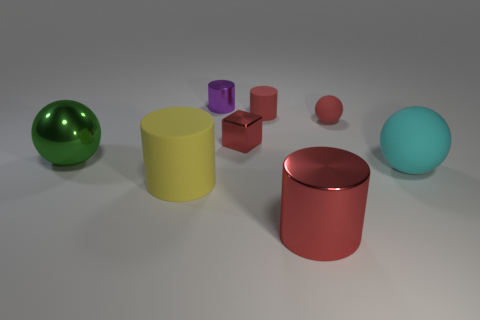What is the big yellow thing made of?
Make the answer very short. Rubber. What shape is the red object that is behind the red rubber object on the right side of the large red cylinder?
Your answer should be compact. Cylinder. The rubber thing to the left of the purple metallic thing has what shape?
Ensure brevity in your answer.  Cylinder. How many big shiny cylinders have the same color as the tiny matte sphere?
Your answer should be compact. 1. What is the color of the large rubber cylinder?
Keep it short and to the point. Yellow. There is a red object that is in front of the green metallic sphere; what number of blocks are in front of it?
Ensure brevity in your answer.  0. Do the red metallic block and the ball behind the metal cube have the same size?
Your answer should be compact. Yes. Do the cyan matte sphere and the green thing have the same size?
Give a very brief answer. Yes. Are there any purple metallic cylinders that have the same size as the cyan matte sphere?
Make the answer very short. No. There is a red cylinder that is in front of the large yellow rubber object; what is its material?
Offer a terse response. Metal. 